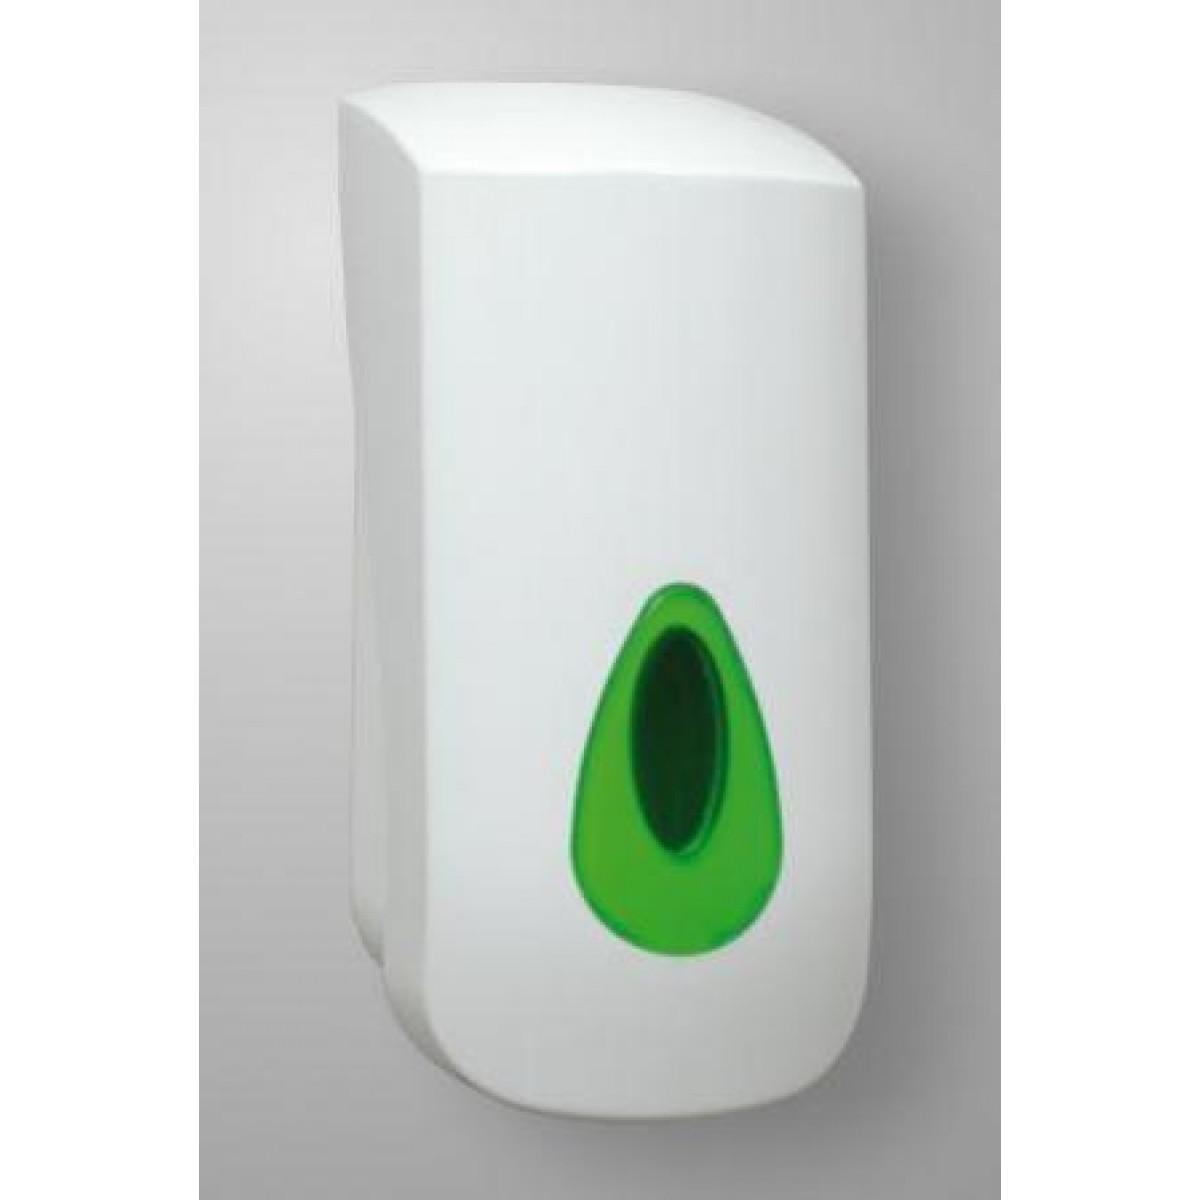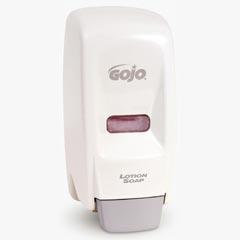The first image is the image on the left, the second image is the image on the right. Considering the images on both sides, is "At least one of the soap dispensers is not white." valid? Answer yes or no. No. The first image is the image on the left, the second image is the image on the right. Considering the images on both sides, is "All of the soap dispensers are primarily white." valid? Answer yes or no. Yes. 